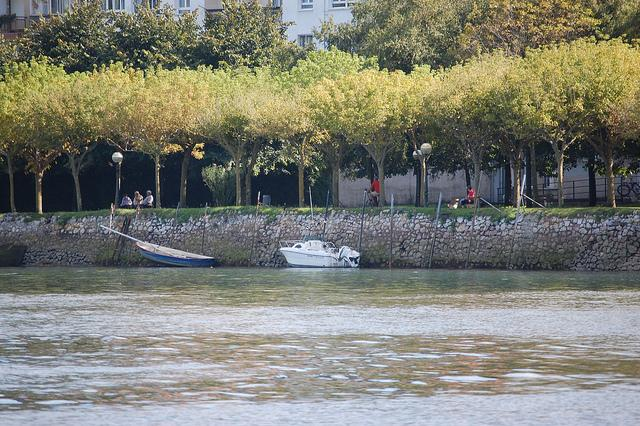What is the black rectangular object in front of the blue boat? ladder 